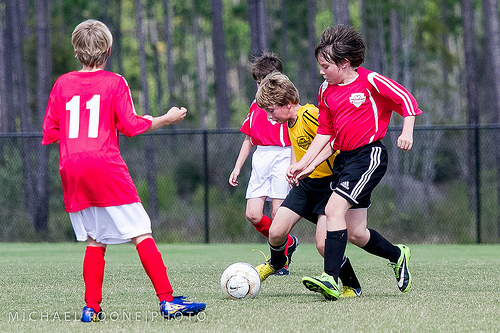<image>
Is there a person to the right of the person? Yes. From this viewpoint, the person is positioned to the right side relative to the person. Where is the ball in relation to the boy? Is it in front of the boy? Yes. The ball is positioned in front of the boy, appearing closer to the camera viewpoint. 